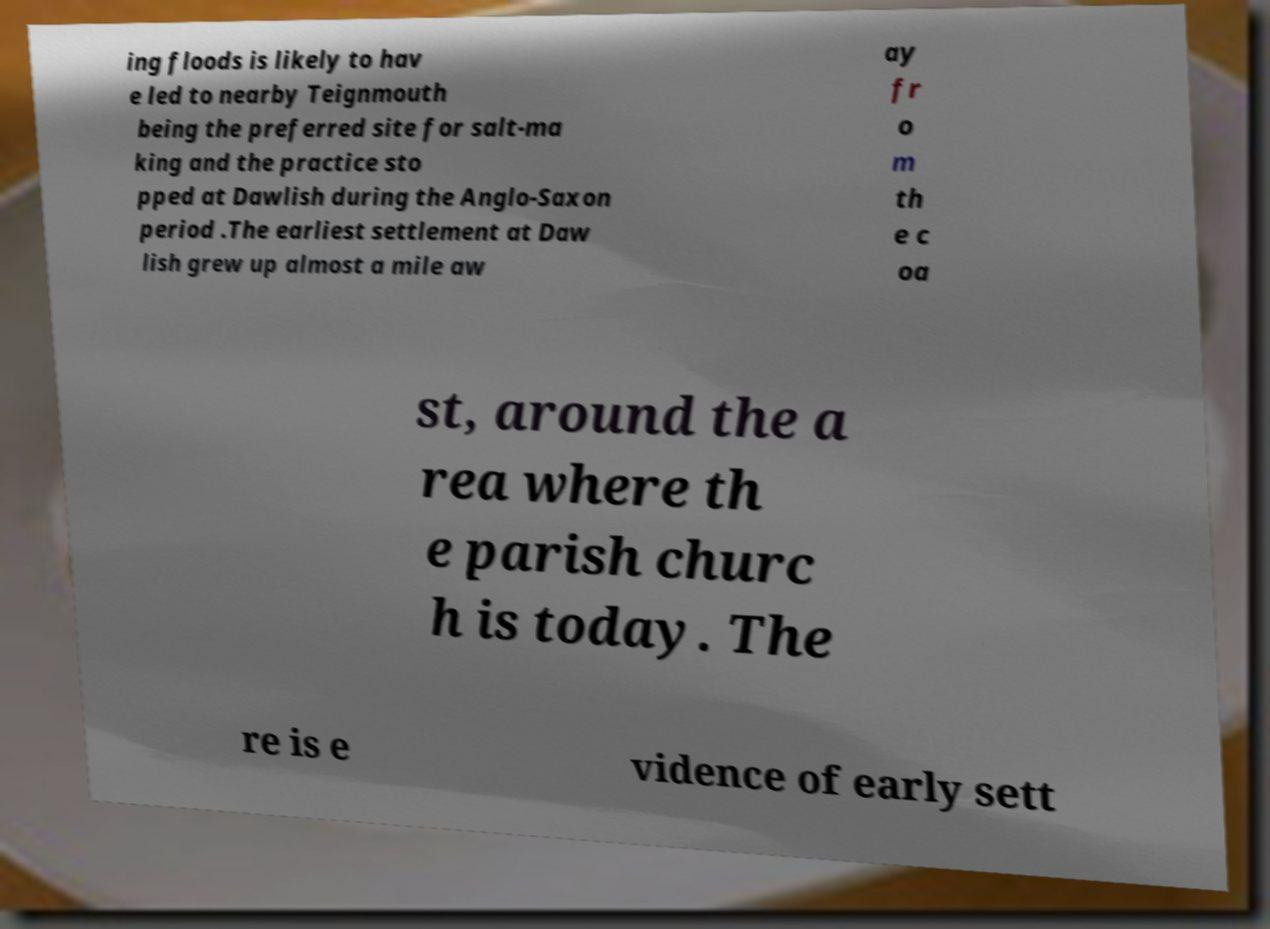For documentation purposes, I need the text within this image transcribed. Could you provide that? ing floods is likely to hav e led to nearby Teignmouth being the preferred site for salt-ma king and the practice sto pped at Dawlish during the Anglo-Saxon period .The earliest settlement at Daw lish grew up almost a mile aw ay fr o m th e c oa st, around the a rea where th e parish churc h is today. The re is e vidence of early sett 